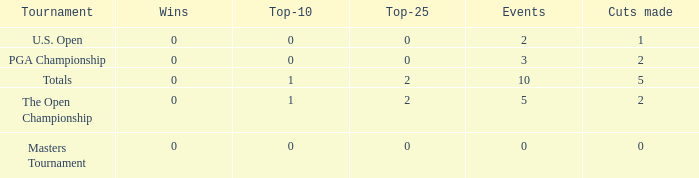What is the total number of top-25s for events with 0 wins? 0.0. 